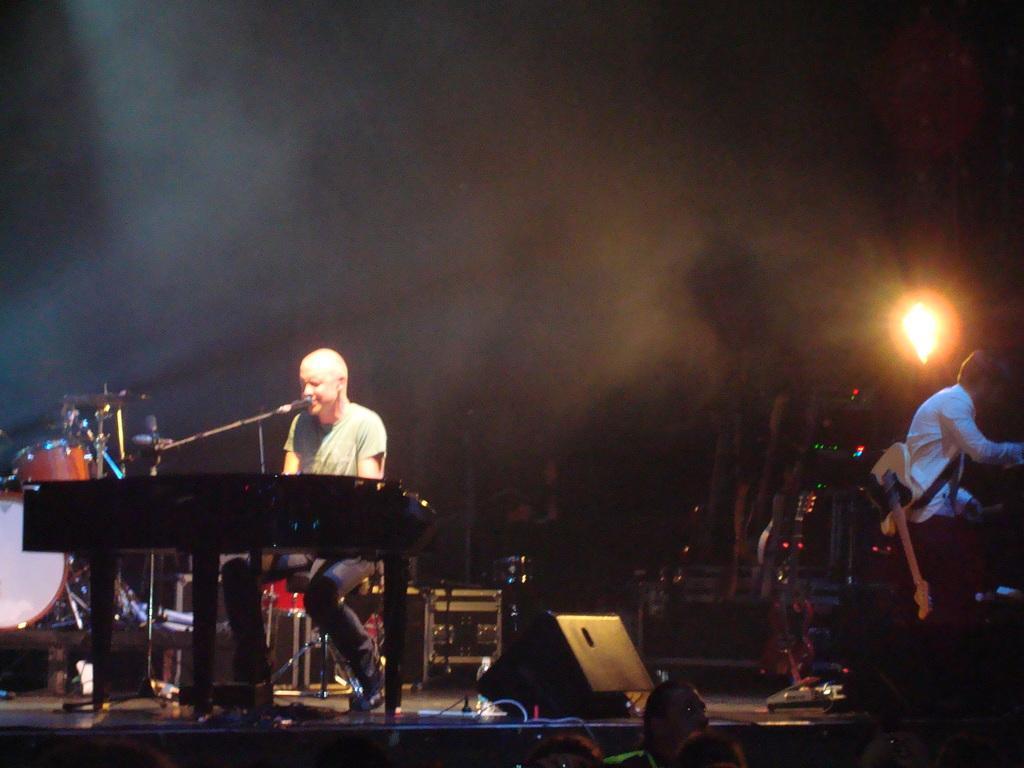Please provide a concise description of this image. In this image there is a man sitting and playing a piano, and singing a song in the microphone , and in back ground there is speaker , another man sitting and drums. 